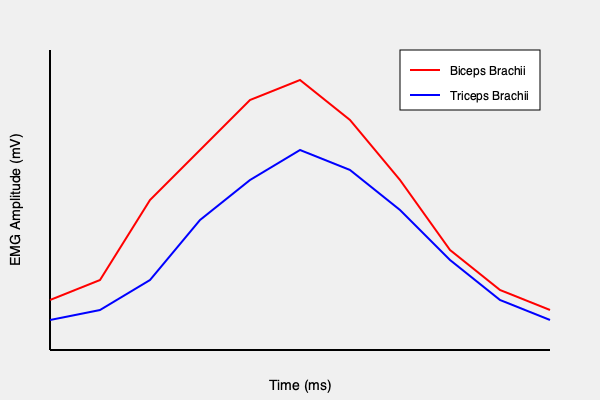Analyze the EMG chart showing muscle activation patterns during a bicep curl exercise. What can be inferred about the roles of the biceps brachii and triceps brachii muscles throughout the movement, and how does this relate to the principle of reciprocal inhibition in weightlifting? To answer this question, let's analyze the EMG chart step-by-step:

1. Interpreting the chart:
   - The red line represents the biceps brachii activation.
   - The blue line represents the triceps brachii activation.
   - The x-axis shows time progression during the bicep curl.
   - The y-axis represents the EMG amplitude, indicating muscle activation intensity.

2. Biceps brachii activation (red line):
   - Starts with low activation at the beginning of the movement.
   - Rapidly increases, reaching peak activation around the middle of the curl.
   - Gradually decreases towards the end of the movement.

3. Triceps brachii activation (blue line):
   - Begins with slightly higher activation compared to the biceps.
   - Decreases as the biceps activation increases.
   - Shows minimal activation when biceps activation is at its peak.
   - Increases again towards the end of the movement.

4. Muscle roles during the bicep curl:
   - Biceps brachii: Primary agonist, responsible for elbow flexion.
   - Triceps brachii: Antagonist, controls the movement and provides stability.

5. Reciprocal inhibition principle:
   - As the agonist (biceps) contracts, the antagonist (triceps) relaxes.
   - This principle is evident in the chart, where biceps activation increases while triceps activation decreases.
   - Reciprocal inhibition allows for smooth, controlled movement and prevents co-contraction of opposing muscles.

6. Practical implications for weightlifting:
   - Understanding this pattern helps in optimizing lifting technique.
   - Proper engagement of the agonist muscle (biceps) is crucial for effective bicep curls.
   - The antagonist muscle (triceps) plays a role in stabilizing the joint and controlling the eccentric phase of the movement.

In conclusion, the EMG chart demonstrates the principle of reciprocal inhibition in action during a bicep curl, showing the coordinated activation and relaxation of the biceps and triceps muscles to produce an efficient and controlled movement.
Answer: The chart shows reciprocal inhibition between biceps and triceps during a bicep curl, with biceps acting as the primary agonist and triceps as the antagonist, enabling smooth and controlled movement. 